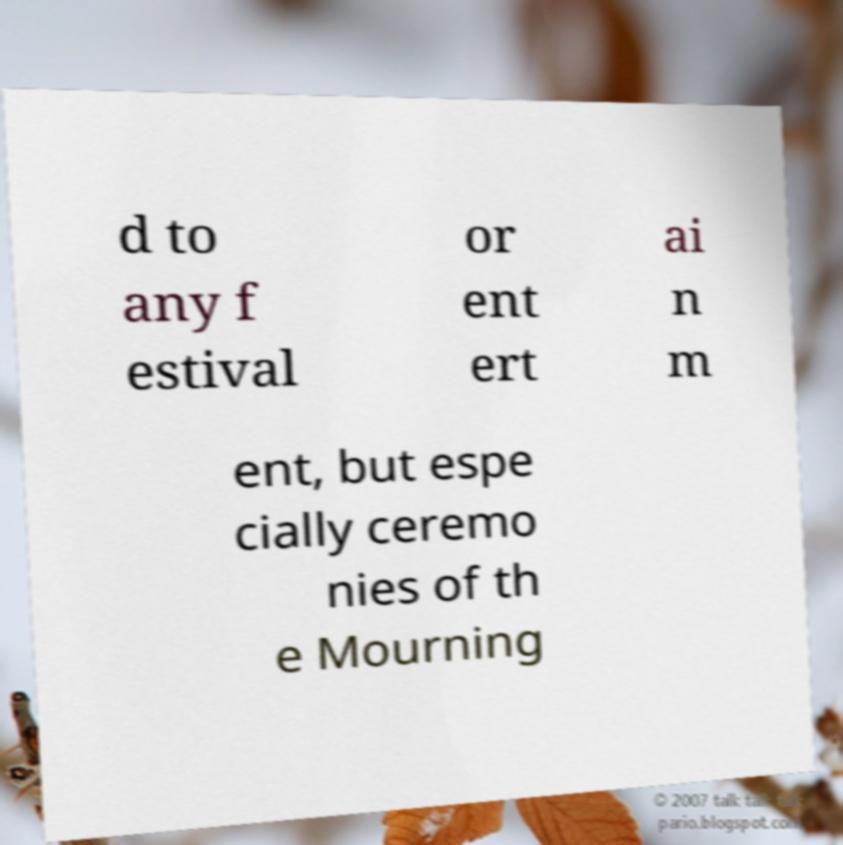What messages or text are displayed in this image? I need them in a readable, typed format. d to any f estival or ent ert ai n m ent, but espe cially ceremo nies of th e Mourning 